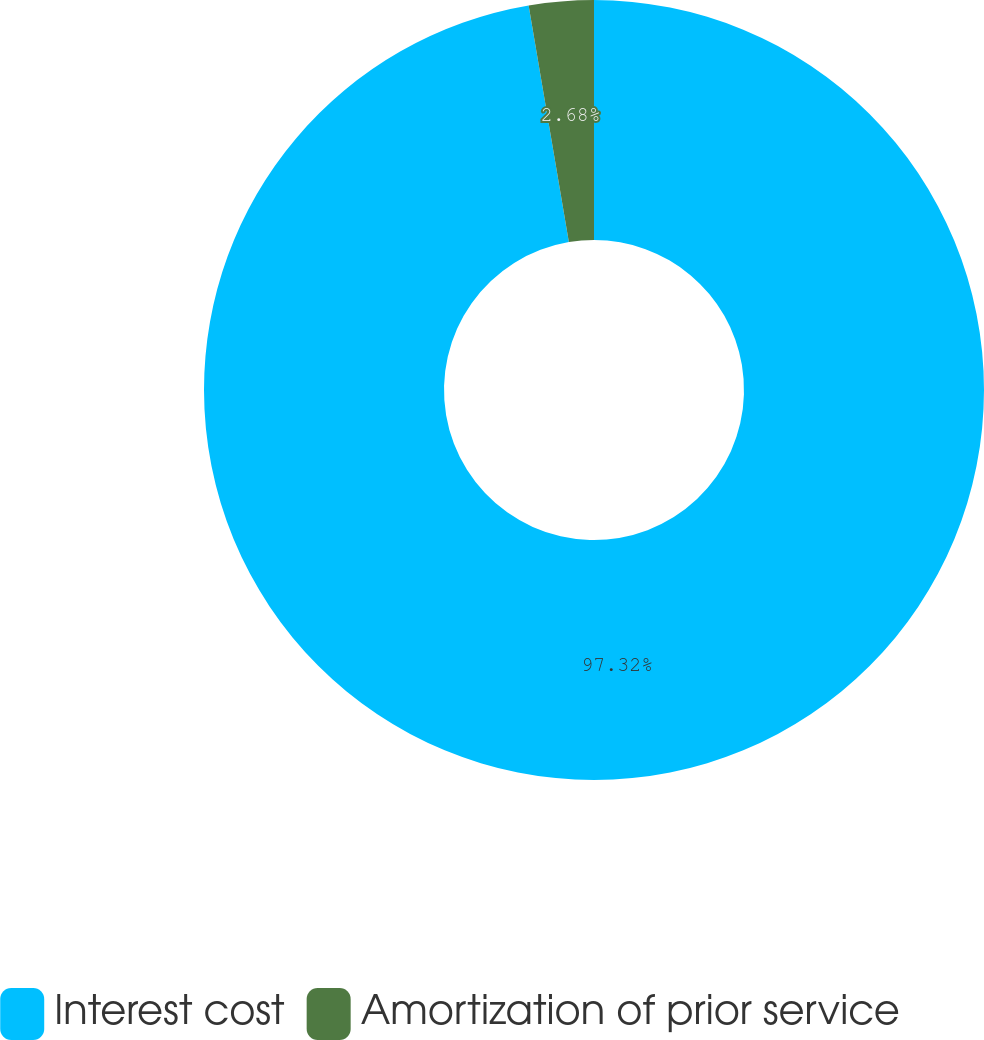<chart> <loc_0><loc_0><loc_500><loc_500><pie_chart><fcel>Interest cost<fcel>Amortization of prior service<nl><fcel>97.32%<fcel>2.68%<nl></chart> 